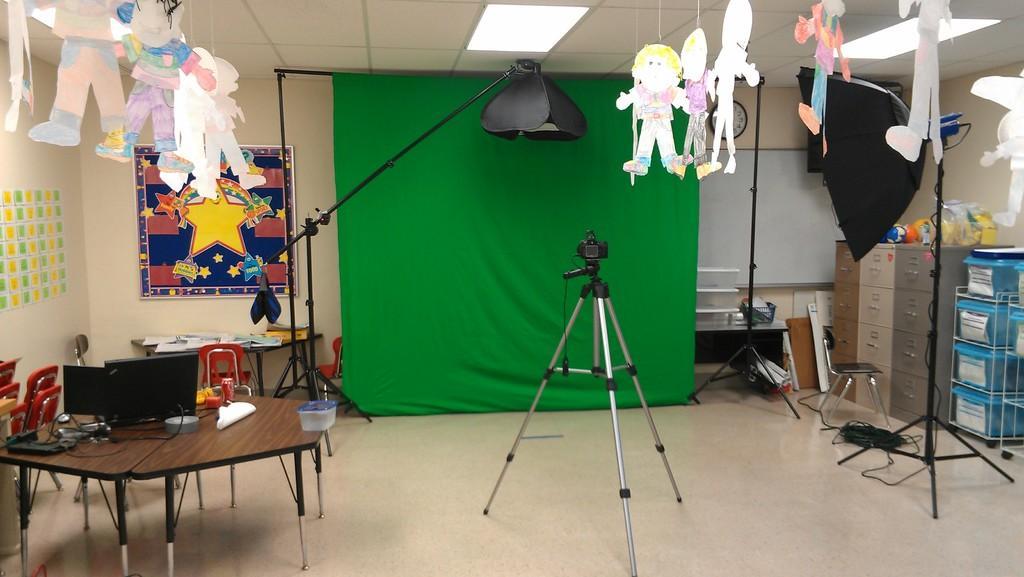In one or two sentences, can you explain what this image depicts? In this image in the middle there is a camera and stand. On the left there is a table on that there are monitors, boxes, tins, some other items. On the right there are cupboards, shelves, boxes, decoration items, chairs, cables, lights. In the middle there are tables, chairs, posters, decorations, lights, cloth, stands, lamp and a wall. 